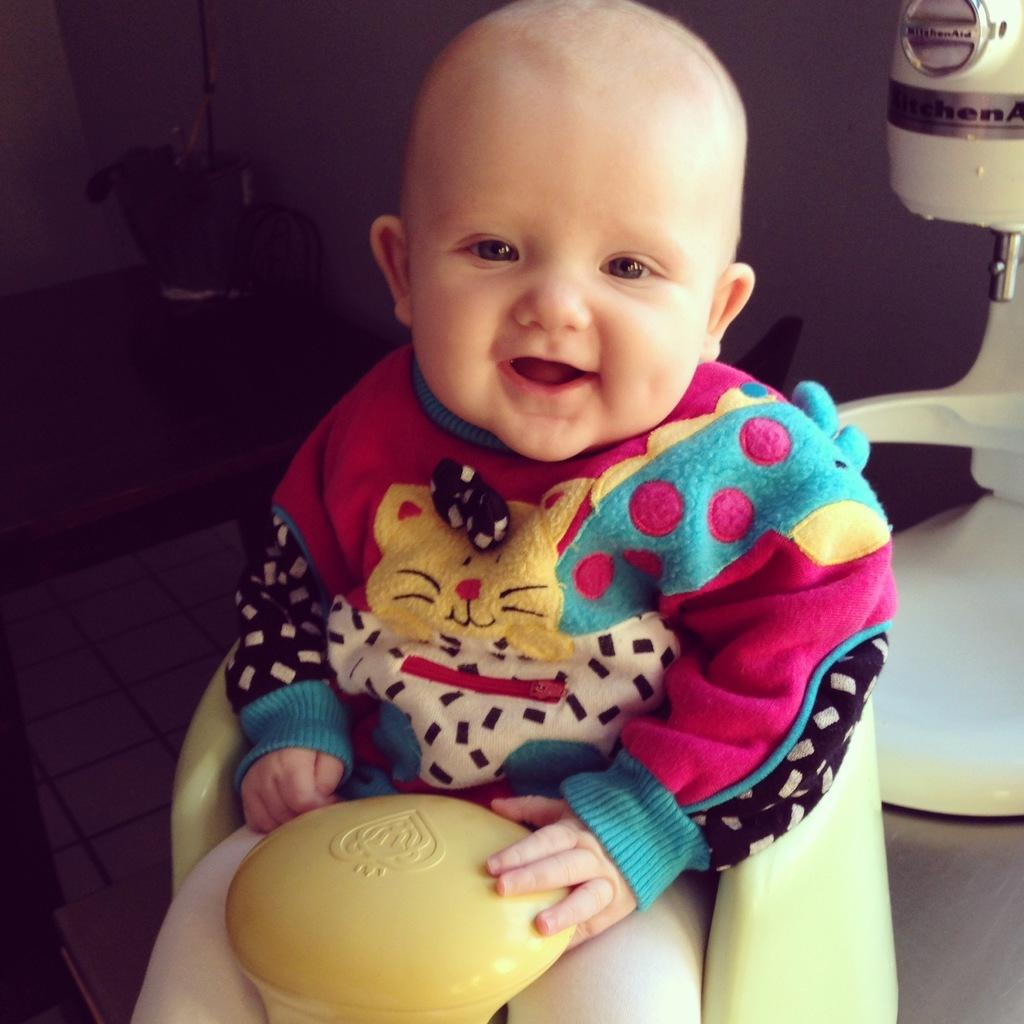What is the main subject of the image? The main subject of the image is a baby. Where is the baby located in the image? The baby is sitting on a chair in the image. What is the baby doing in the image? The baby is laughing in the image. What type of donkey can be seen in the image? There is no donkey present in the image. What color is the sky in the image? The provided facts do not mention the color of the sky, and the image does not show the sky. 